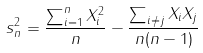<formula> <loc_0><loc_0><loc_500><loc_500>s _ { n } ^ { 2 } = \frac { \sum _ { i = 1 } ^ { n } X _ { i } ^ { 2 } } { n } - \frac { \sum _ { i \neq j } X _ { i } X _ { j } } { n ( n - 1 ) }</formula> 